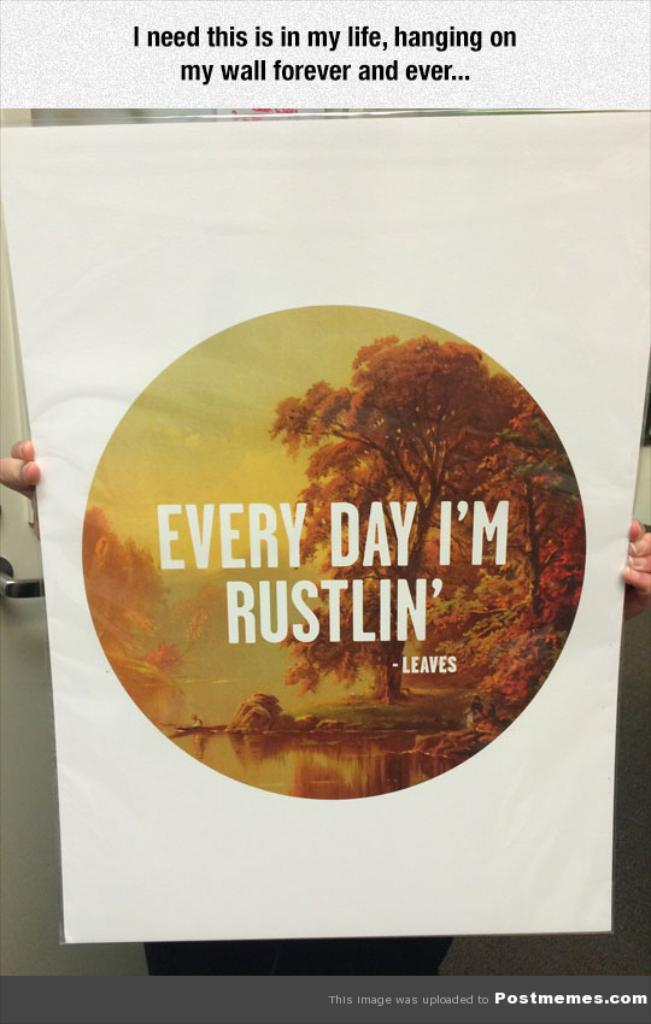Provide a one-sentence caption for the provided image. A person holding an Every Day I'm Rustlin' poster. 